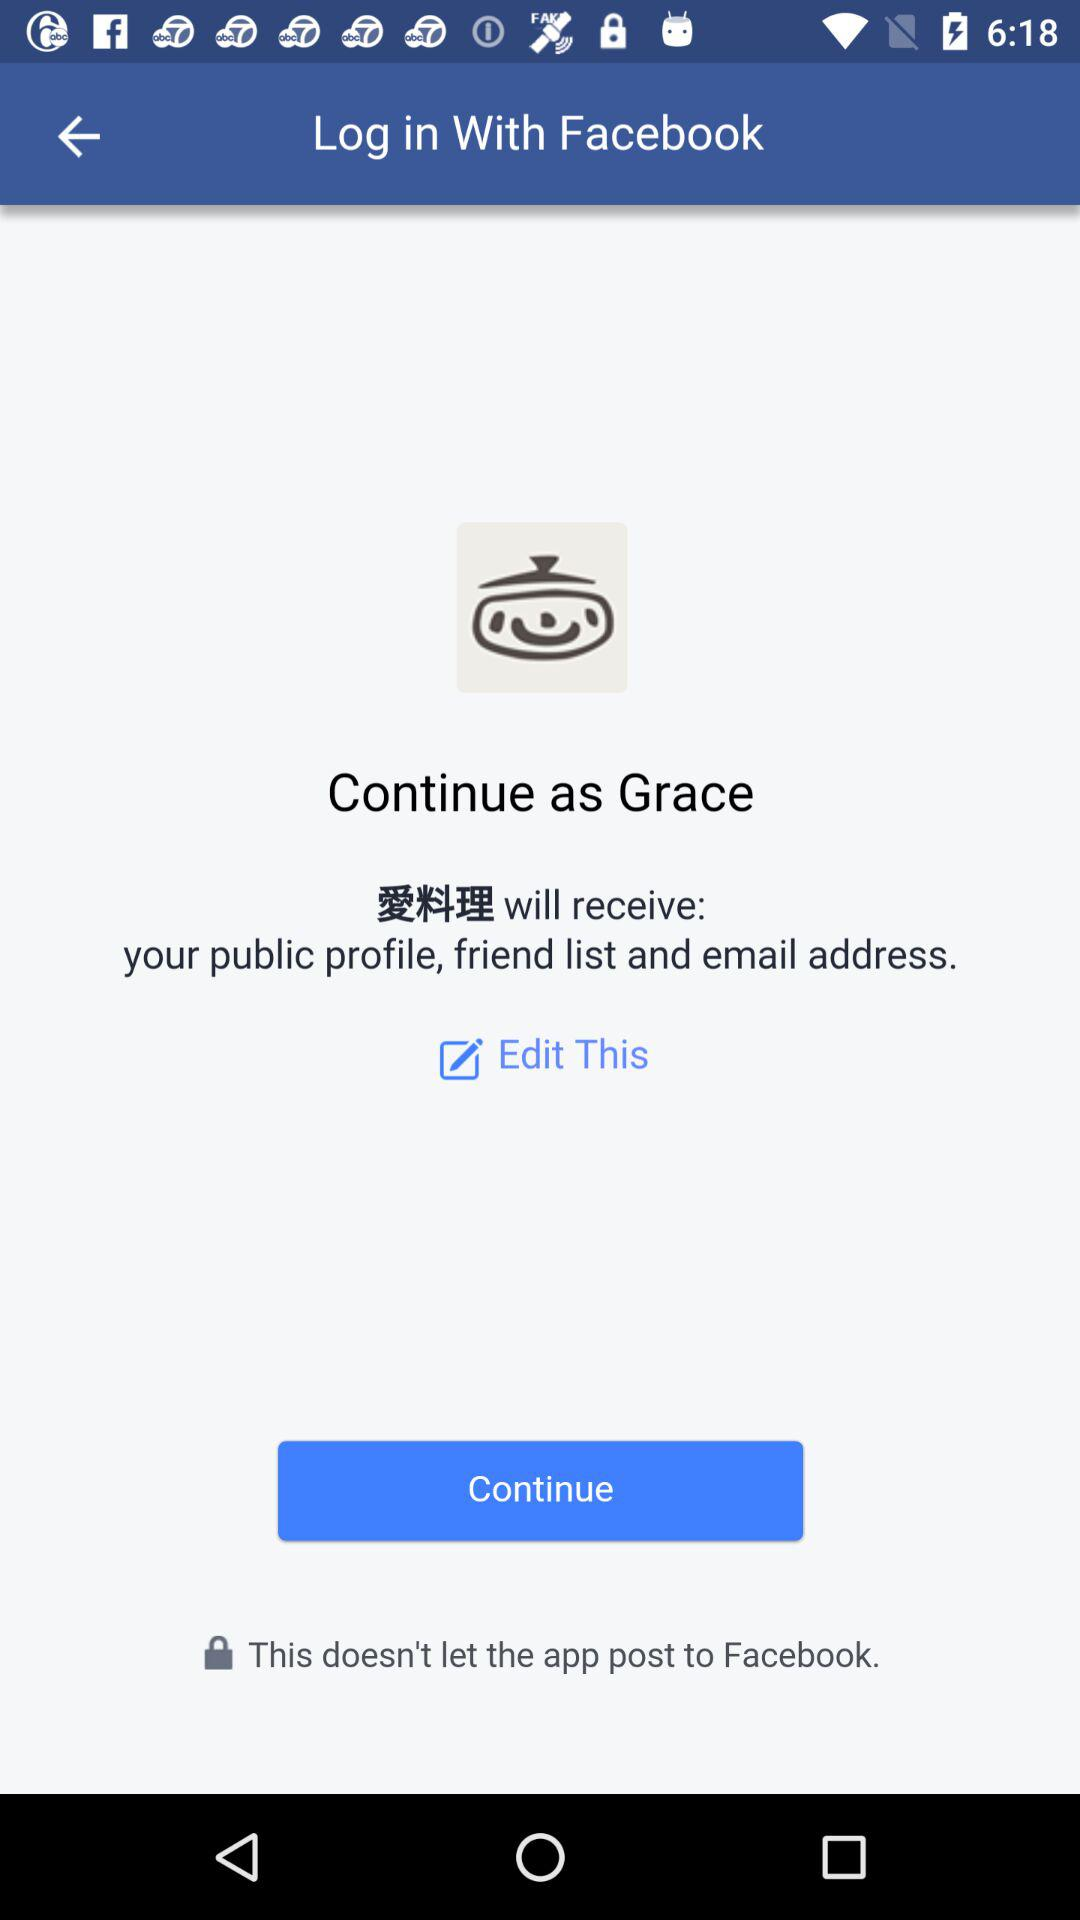What is the name of the user? The name of the user is Grace. 